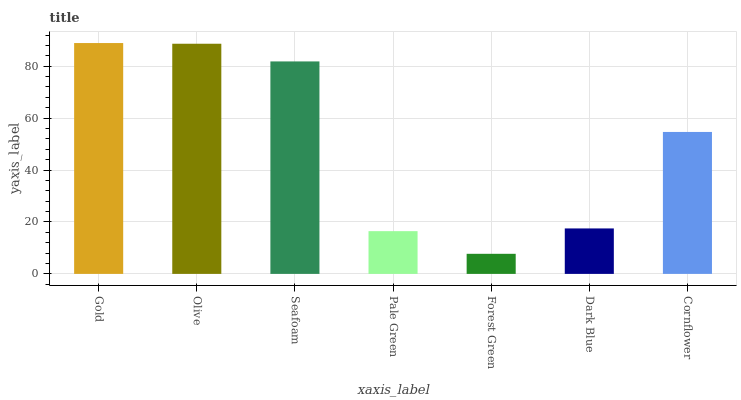Is Forest Green the minimum?
Answer yes or no. Yes. Is Gold the maximum?
Answer yes or no. Yes. Is Olive the minimum?
Answer yes or no. No. Is Olive the maximum?
Answer yes or no. No. Is Gold greater than Olive?
Answer yes or no. Yes. Is Olive less than Gold?
Answer yes or no. Yes. Is Olive greater than Gold?
Answer yes or no. No. Is Gold less than Olive?
Answer yes or no. No. Is Cornflower the high median?
Answer yes or no. Yes. Is Cornflower the low median?
Answer yes or no. Yes. Is Dark Blue the high median?
Answer yes or no. No. Is Pale Green the low median?
Answer yes or no. No. 